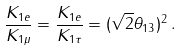<formula> <loc_0><loc_0><loc_500><loc_500>\frac { K _ { 1 e } } { K _ { 1 \mu } } = \frac { K _ { 1 e } } { K _ { 1 \tau } } = ( \sqrt { 2 } \theta _ { 1 3 } ) ^ { 2 } \, .</formula> 